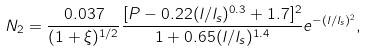<formula> <loc_0><loc_0><loc_500><loc_500>N _ { 2 } = \frac { 0 . 0 3 7 } { ( 1 + \xi ) ^ { 1 / 2 } } \frac { [ P - 0 . 2 2 ( l / l _ { s } ) ^ { 0 . 3 } + 1 . 7 ] ^ { 2 } } { 1 + 0 . 6 5 ( l / l _ { s } ) ^ { 1 . 4 } } e ^ { - ( l / l _ { s } ) ^ { 2 } } ,</formula> 